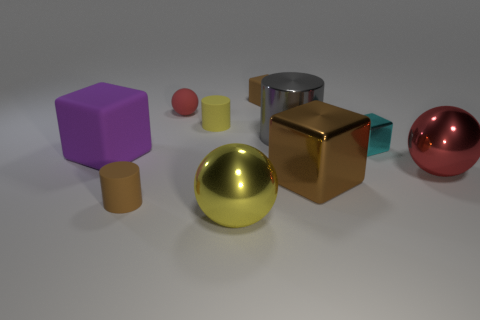There is a thing that is the same color as the tiny ball; what is its material?
Give a very brief answer. Metal. Is the color of the tiny rubber cube the same as the big metal block?
Make the answer very short. Yes. What number of objects are brown rubber objects or large green cubes?
Offer a terse response. 2. There is a big block that is on the right side of the cylinder that is in front of the big sphere behind the brown cylinder; what is it made of?
Your answer should be very brief. Metal. There is a big gray object that is in front of the matte ball; what material is it?
Offer a very short reply. Metal. Are there any red metal spheres that have the same size as the gray metal thing?
Your answer should be very brief. Yes. Does the big sphere right of the cyan metal cube have the same color as the matte sphere?
Your response must be concise. Yes. How many purple objects are small rubber spheres or shiny balls?
Offer a terse response. 0. How many matte blocks have the same color as the small metallic object?
Ensure brevity in your answer.  0. Do the tiny ball and the purple cube have the same material?
Your response must be concise. Yes. 